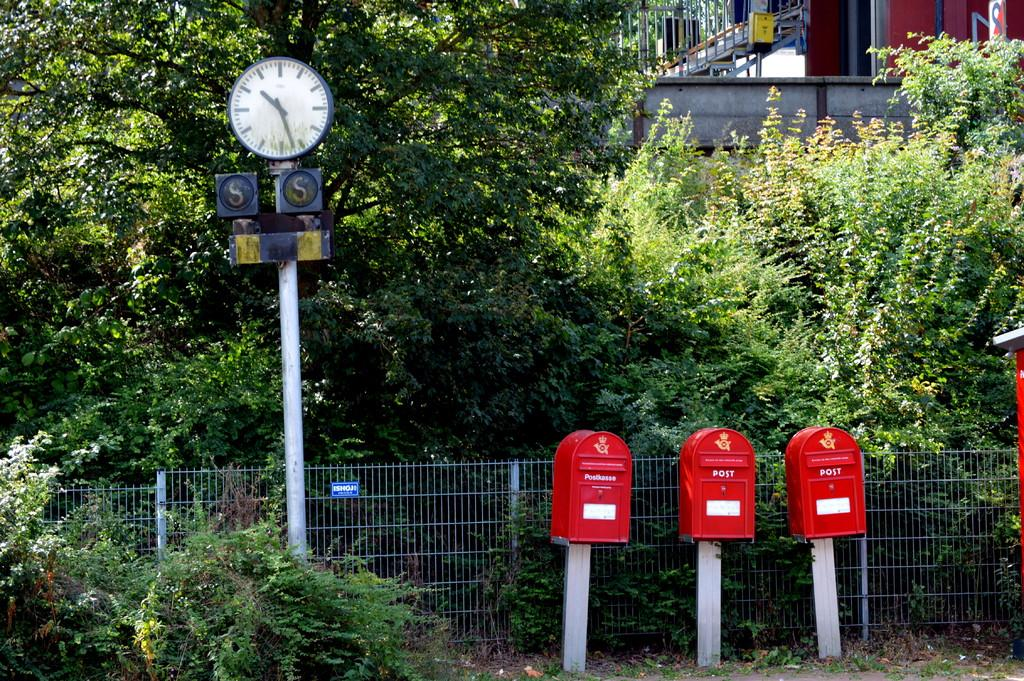How many post boxes are visible in the image? There are three post boxes in the image. What is located behind the post boxes? There is a fencing behind the post boxes. What type of vegetation can be seen in the image? There are trees and plants in the image. What type of structure is present in the image? There is a house in the image. What architectural feature is associated with the house? The house has a staircase. Is there any fencing associated with the house's staircase? Yes, there is a fencing associated with the house's staircase. What type of insurance is being offered by the post boxes in the image? There is no indication of insurance being offered by the post boxes in the image. What type of competition is taking place in the image? There is no competition present in the image. 